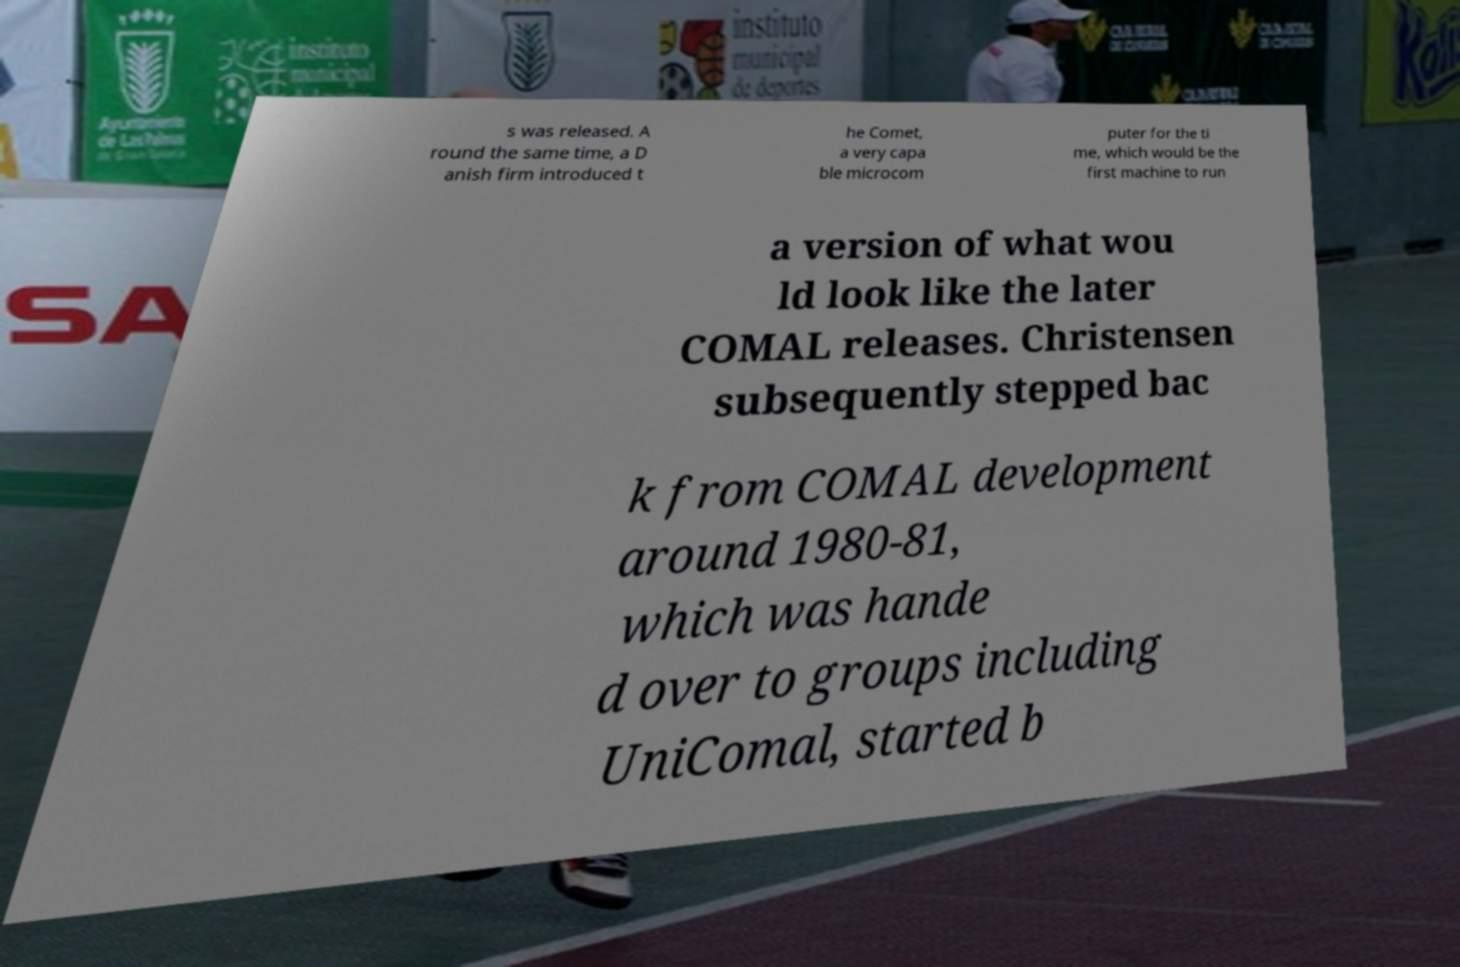Please read and relay the text visible in this image. What does it say? s was released. A round the same time, a D anish firm introduced t he Comet, a very capa ble microcom puter for the ti me, which would be the first machine to run a version of what wou ld look like the later COMAL releases. Christensen subsequently stepped bac k from COMAL development around 1980-81, which was hande d over to groups including UniComal, started b 